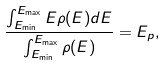Convert formula to latex. <formula><loc_0><loc_0><loc_500><loc_500>\frac { \int _ { E _ { \min } } ^ { E _ { \max } } E \rho ( E ) d E } { \int _ { E _ { \min } } ^ { E _ { \max } } \rho ( E ) } = E _ { p } ,</formula> 